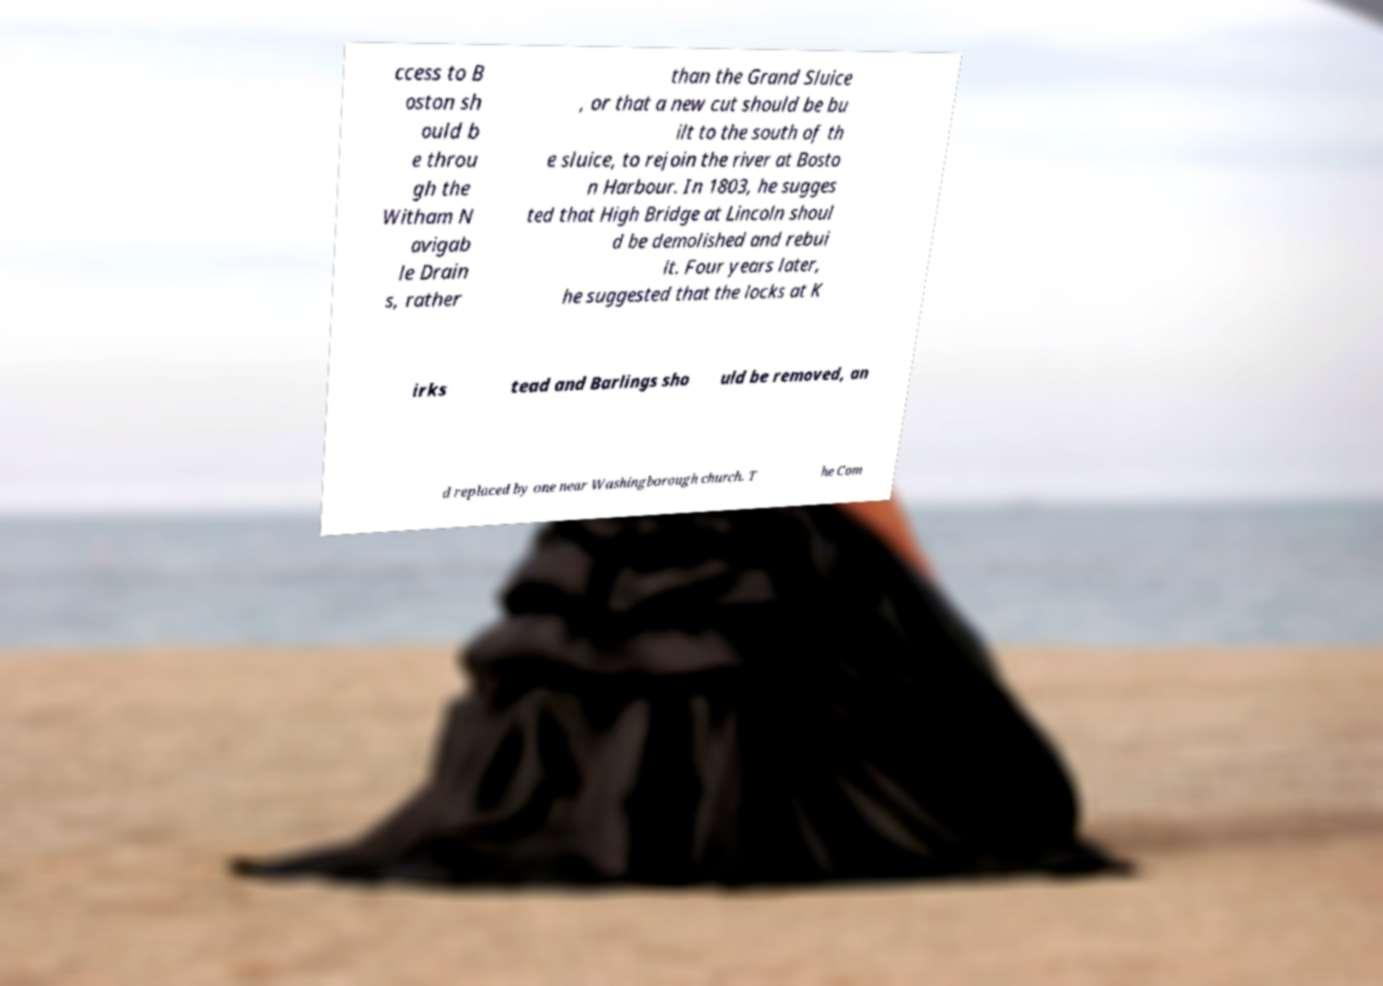What messages or text are displayed in this image? I need them in a readable, typed format. ccess to B oston sh ould b e throu gh the Witham N avigab le Drain s, rather than the Grand Sluice , or that a new cut should be bu ilt to the south of th e sluice, to rejoin the river at Bosto n Harbour. In 1803, he sugges ted that High Bridge at Lincoln shoul d be demolished and rebui lt. Four years later, he suggested that the locks at K irks tead and Barlings sho uld be removed, an d replaced by one near Washingborough church. T he Com 